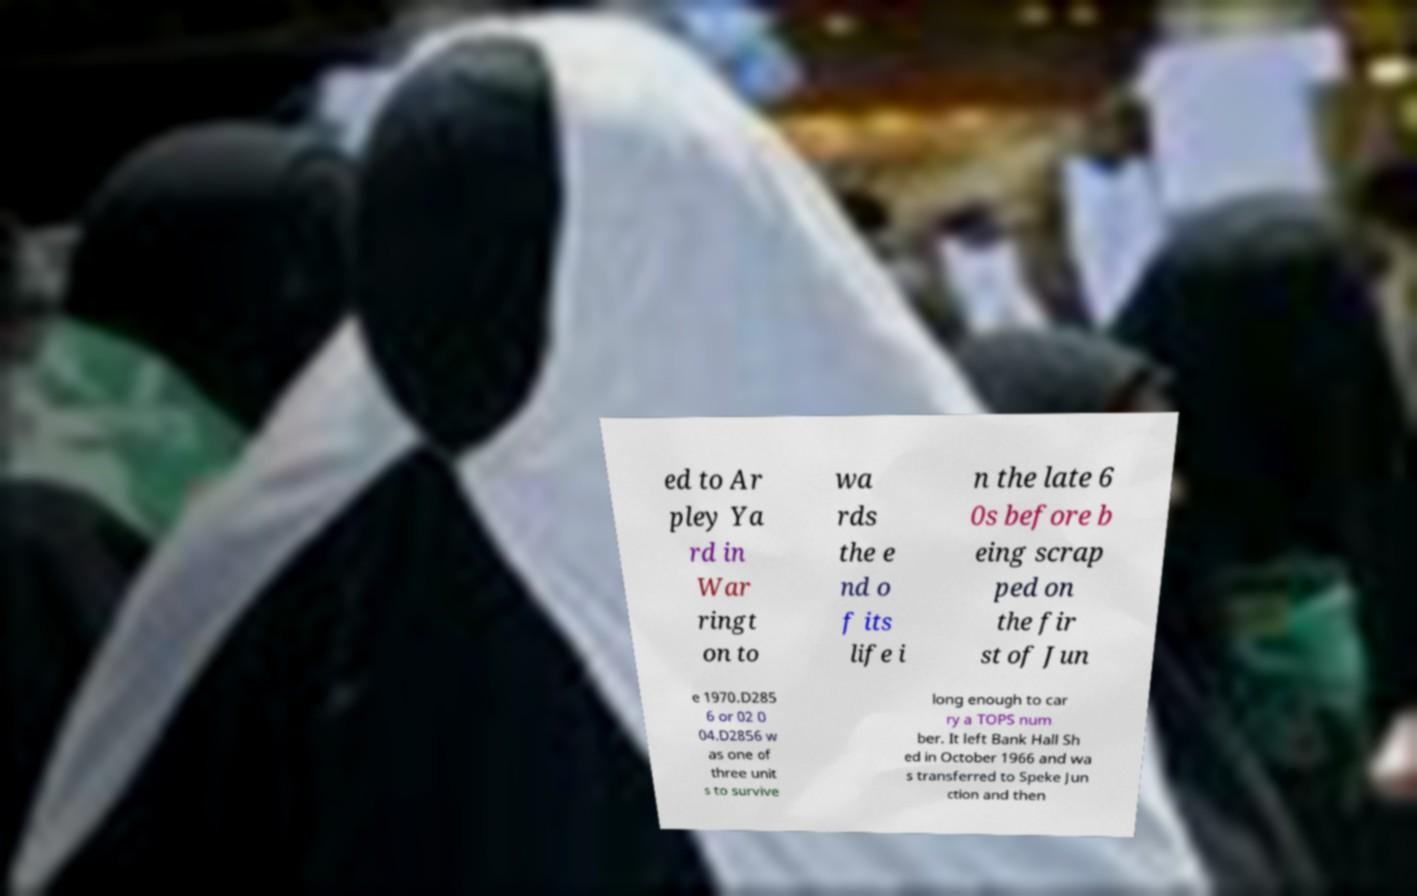Could you extract and type out the text from this image? ed to Ar pley Ya rd in War ringt on to wa rds the e nd o f its life i n the late 6 0s before b eing scrap ped on the fir st of Jun e 1970.D285 6 or 02 0 04.D2856 w as one of three unit s to survive long enough to car ry a TOPS num ber. It left Bank Hall Sh ed in October 1966 and wa s transferred to Speke Jun ction and then 